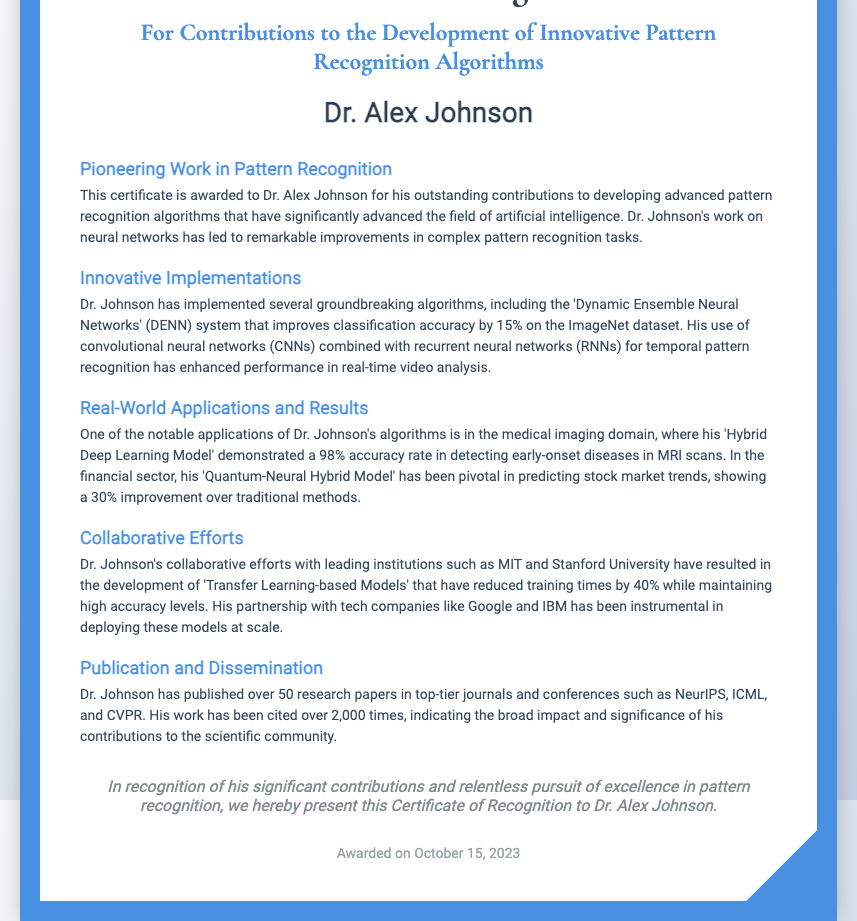What is the recipient's name? The document specifically names the recipient of the certificate as Dr. Alex Johnson.
Answer: Dr. Alex Johnson What is the title of the certificate? The title of the certificate indicates recognition for contributions to the development of innovative pattern recognition algorithms.
Answer: Contributions to the Development of Innovative Pattern Recognition Algorithms Which algorithm improved classification accuracy by 15%? The document states that the 'Dynamic Ensemble Neural Networks' (DENN) system achieved this improvement on the ImageNet dataset.
Answer: Dynamic Ensemble Neural Networks What is the accuracy rate of the Hybrid Deep Learning Model in medical imaging? The document highlights that this model achieved a 98% accuracy rate in detecting early-onset diseases in MRI scans.
Answer: 98% What institutions did Dr. Johnson collaborate with? The document mentions collaborative efforts with leading institutions such as MIT and Stanford University.
Answer: MIT and Stanford University What was the improvement percentage of the Quantum-Neural Hybrid Model? The document notes that this model showed a 30% improvement over traditional methods in predicting stock market trends.
Answer: 30% How many research papers has Dr. Johnson published? The document states that Dr. Johnson has published over 50 research papers in top-tier journals and conferences.
Answer: Over 50 When was the certificate awarded? The document specifies that the certificate was awarded on October 15, 2023.
Answer: October 15, 2023 What has been the citation count for Dr. Johnson's work? The document indicates that his work has been cited over 2,000 times.
Answer: Over 2,000 